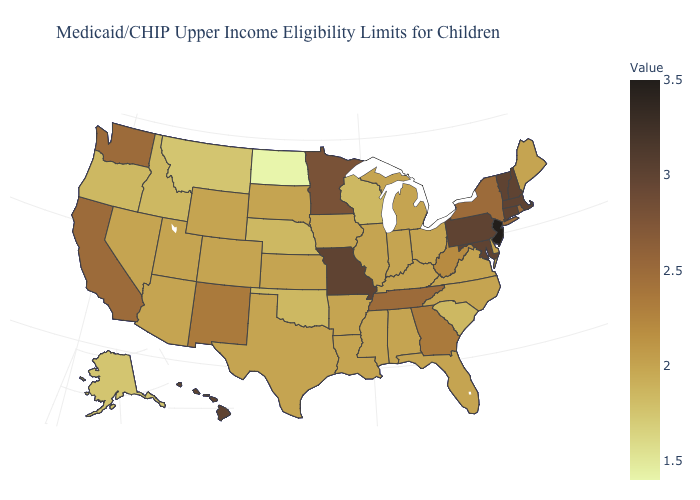Among the states that border West Virginia , does Pennsylvania have the lowest value?
Keep it brief. No. Which states have the lowest value in the MidWest?
Give a very brief answer. North Dakota. Which states hav the highest value in the MidWest?
Answer briefly. Missouri. Among the states that border Virginia , does Kentucky have the highest value?
Be succinct. No. Does South Dakota have a lower value than Montana?
Short answer required. No. 